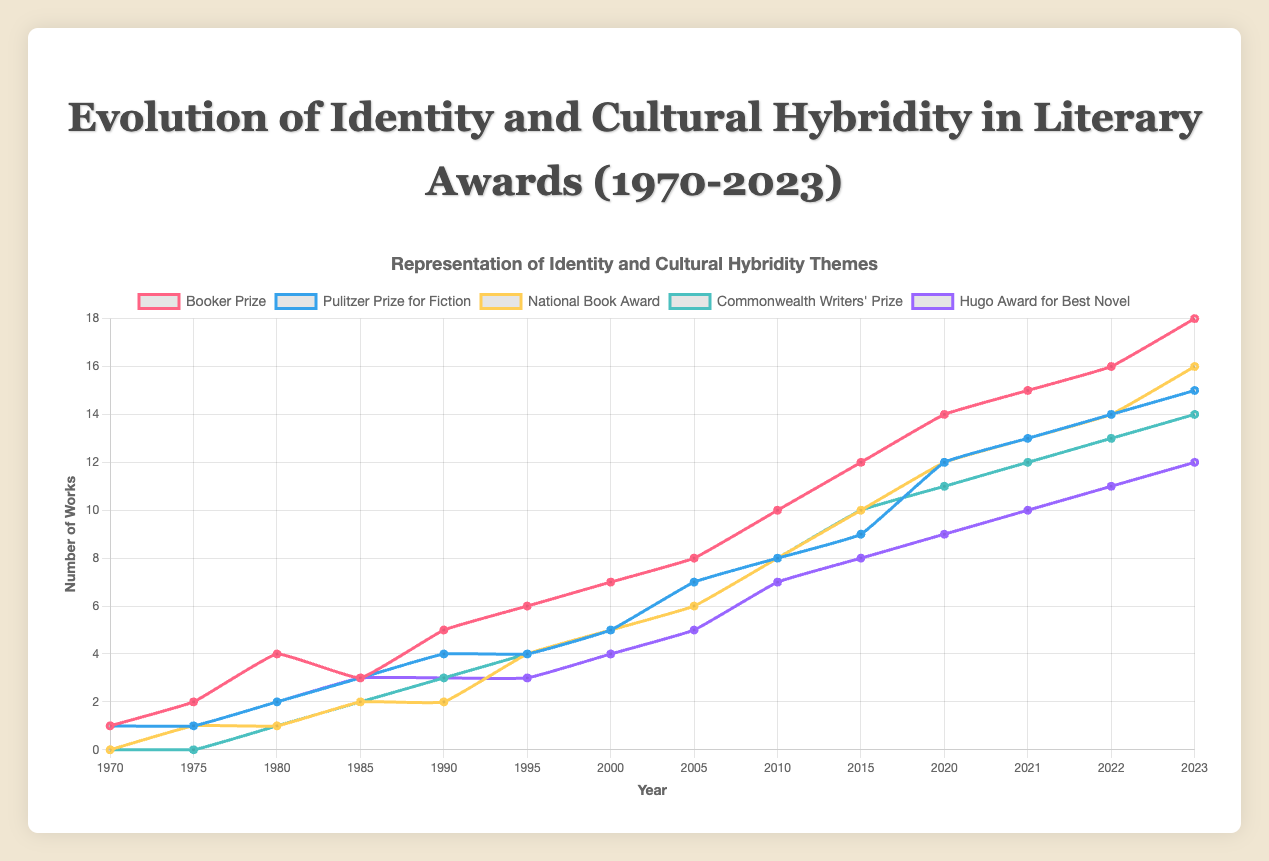Which prize showed the highest representation of identity and cultural hybridity themes in 2023? Observing the endpoints of the lines representing each prize, the Booker Prize has the highest value in 2023, reaching 18.
Answer: Booker Prize How did the representation of identity and cultural hybridity themes in the National Book Award change between 1990 and 2000? In 1990, the National Book Award value was 2. By 2000, it increased to 5. The change is calculated as 5 - 2 = 3.
Answer: Increased by 3 Which prize had the most rapid increase in representation between 2010 and 2015? Comparing the slopes of the lines between 2010 and 2015, the Booker Prize increased from 10 to 12 (a change of 2), while the National Book Award increased from 8 to 10 (a change of 2). However, the Commonwealth Writers' Prize increased from 8 to 10 as well. Each increase is by 2, implying they all had similar increases.
Answer: Booker Prize, National Book Award, Commonwealth Writers' Prize Which prize had the least representation of identity and cultural hybridity themes in 1980? Observing the points at 1980, the National Book Award and Commonwealth Writers' Prize each have values of 1, the lowest among the prizes shown.
Answer: National Book Award, Commonwealth Writers' Prize How did the Booker Prize's representation of identity and cultural hybridity themes compare to the Pulitzer Prize for Fiction in 1995? In 1995, the Booker Prize's value is 6, while the Pulitzer Prize for Fiction is 4.
Answer: The Booker Prize had a higher representation Which prize saw a faster rate of growth from 1970 to 1985, Booker Prize or Hugo Award for Best Novel? The Booker Prize grew from 1 to 3, while the Hugo Award for Best Novel grew from 1 to 3 over the same period, indicating the same rate of growth.
Answer: Same rate of growth What was the average representation of identity and cultural hybridity themes for the Commonwealth Writers' Prize from 2000 to 2010? The values from 2000 to 2010 for the Commonwealth Writers' Prize are 5, 6, 8. Summing these gives 19 and dividing by 3 yields 6.33 (repeating).
Answer: Approximately 6.33 Between 2020 and 2023, which prize had the smallest increase in representation? Comparing the increases: Booker Prize (14 to 18, +4), Pulitzer Prize (12 to 15, +3), National Book Award (12 to 16, +4), Commonwealth Writers' Prize (11 to 14, +3), Hugo Award (9 to 12, +3). The Pulitzer Prize, Commonwealth Writers' Prize, and Hugo Award had the smallest increases of +3.
Answer: Pulitzer Prize, Commonwealth Writers' Prize, Hugo Award By 2023, which prizes have reached or surpassed 15 in representation? Checking the 2023 values, the Booker Prize (18), Pulitzer Prize for Fiction (15), and National Book Award (16) all reached or surpassed 15.
Answer: Booker Prize, Pulitzer Prize for Fiction, National Book Award 